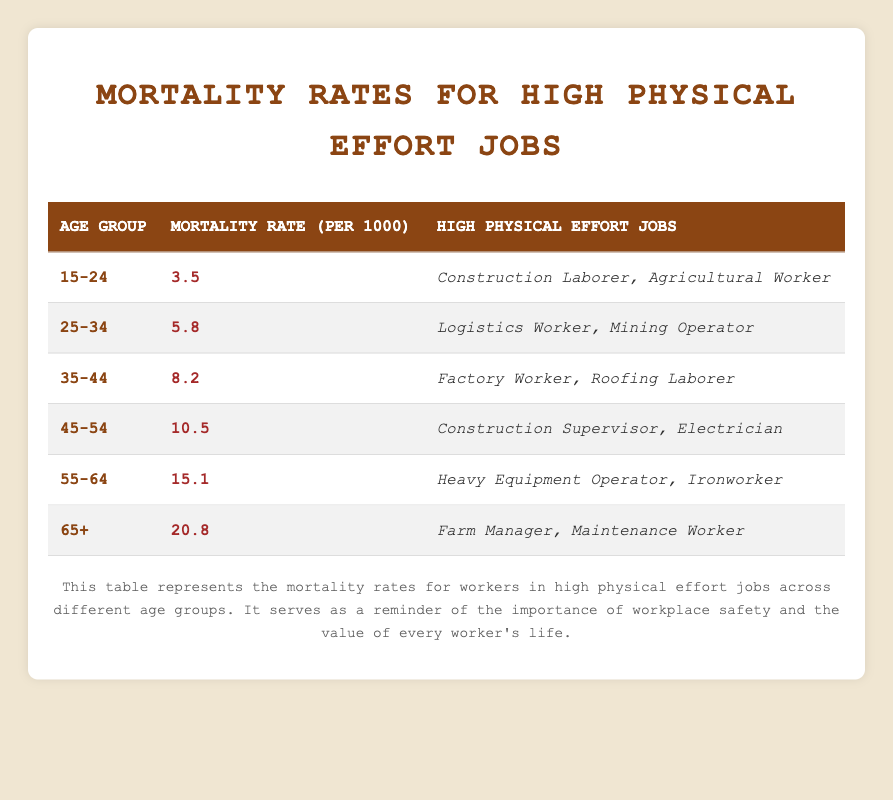What is the mortality rate for the age group 45-54? The table lists a specific mortality rate for each age group. By locating the row for the age group 45-54, we find that the mortality rate is 10.5 per 1000.
Answer: 10.5 Which age group has the highest mortality rate? By examining the mortality rates from each age group in the table, we see that the 65+ age group has the highest rate of 20.8 per 1000.
Answer: 65+ How many high physical effort jobs are listed for the age group 55-64? Looking at the corresponding row for the age group 55-64 in the table, there are two high physical effort jobs: Heavy Equipment Operator and Ironworker.
Answer: 2 Is the mortality rate for the age group 35-44 higher than that for 25-34? By comparing the mortality rates, we see that the rate for 35-44 is 8.2 per 1000, while for 25-34, it is 5.8 per 1000. Since 8.2 > 5.8, the statement is true.
Answer: Yes What is the average mortality rate for the age groups under 45? To find the average, we first sum the mortality rates for the age groups 15-24 (3.5), 25-34 (5.8), and 35-44 (8.2). The total is 3.5 + 5.8 + 8.2 = 17.5. There are 3 age groups, so the average is 17.5 / 3 = 5.83.
Answer: 5.83 Which job categories appear for the age group 55-64? The table shows two jobs listed for the age group 55-64: Heavy Equipment Operator and Ironworker.
Answer: Heavy Equipment Operator, Ironworker What is the difference in mortality rates between the age groups 45-54 and 55-64? The mortality rate for 45-54 is 10.5 per 1000 and for 55-64 it is 15.1 per 1000. The difference is calculated as 15.1 - 10.5 = 4.6 per 1000.
Answer: 4.6 Are there more job types listed for the age group 25-34 than for 15-24? For the age group 25-34, there are 2 jobs (Logistics Worker, Mining Operator), and for 15-24, there are also 2 jobs (Construction Laborer, Agricultural Worker). Since both have the same number, the statement is false.
Answer: No What trends can be observed regarding mortality rates from ages 15-24 to 65+? By analyzing the table, we notice a rising trend in mortality rates as age groups increase, starting from 3.5 per 1000 at 15-24 to 20.8 per 1000 at 65+. This indicates increased mortality risk with age, particularly in high physical effort jobs.
Answer: Increasing trend 